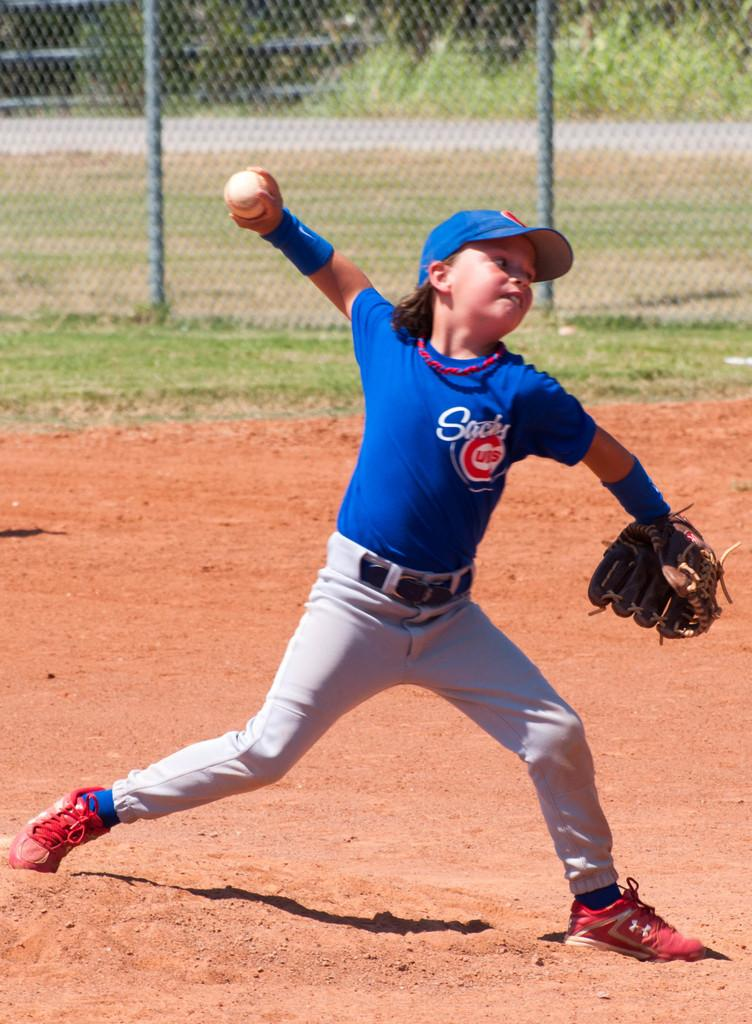<image>
Describe the image concisely. A young baseball player wearing a Cubs shirt is pitching a baseball. 